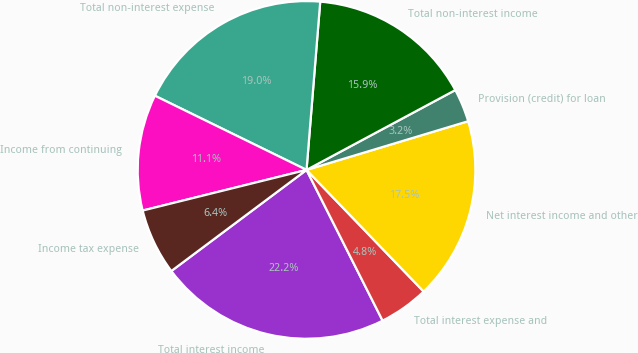Convert chart to OTSL. <chart><loc_0><loc_0><loc_500><loc_500><pie_chart><fcel>Total interest income<fcel>Total interest expense and<fcel>Net interest income and other<fcel>Provision (credit) for loan<fcel>Total non-interest income<fcel>Total non-interest expense<fcel>Income from continuing<fcel>Income tax expense<nl><fcel>22.22%<fcel>4.76%<fcel>17.46%<fcel>3.18%<fcel>15.87%<fcel>19.05%<fcel>11.11%<fcel>6.35%<nl></chart> 